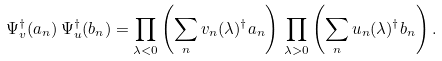Convert formula to latex. <formula><loc_0><loc_0><loc_500><loc_500>\Psi _ { v } ^ { \dagger } ( a _ { n } ) \, \Psi _ { u } ^ { \dagger } ( b _ { n } ) = \prod _ { \lambda < 0 } \left ( \sum _ { n } v _ { n } ( \lambda ) ^ { \dagger } a _ { n } \right ) \, \prod _ { \lambda > 0 } \left ( \sum _ { n } u _ { n } ( \lambda ) ^ { \dagger } b _ { n } \right ) .</formula> 